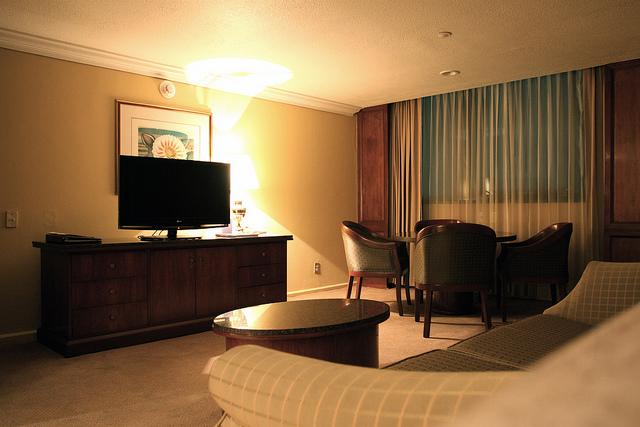Are the drapes open?
Be succinct. No. Is this a hardwood floor?
Concise answer only. No. Is the window small?
Give a very brief answer. No. Is the tv on?
Give a very brief answer. No. 